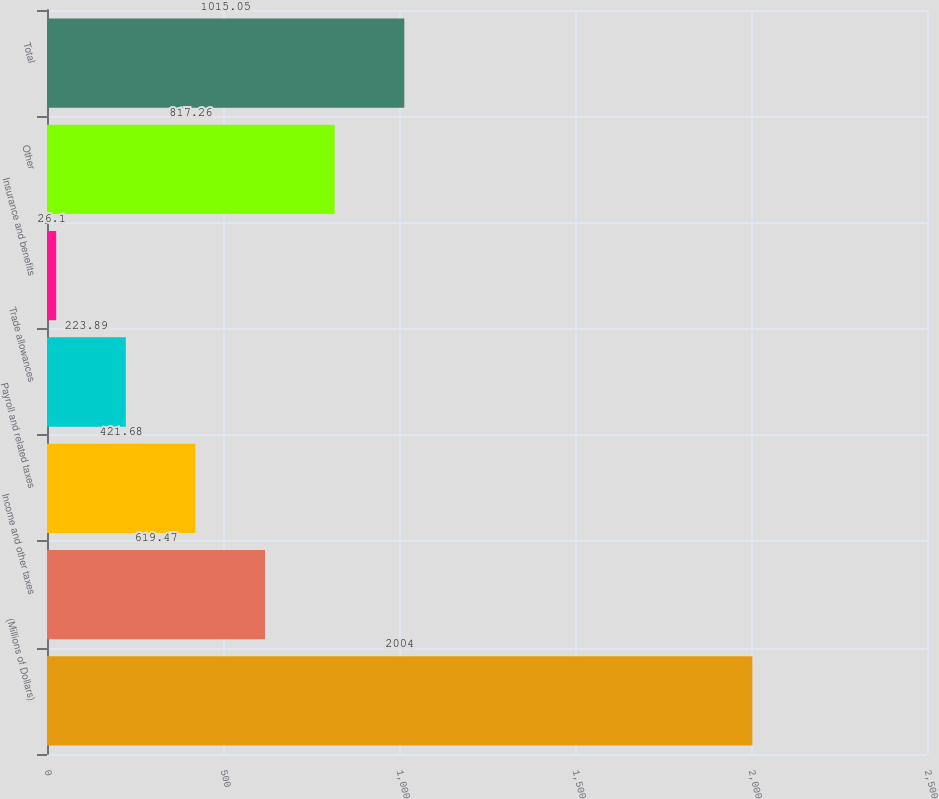<chart> <loc_0><loc_0><loc_500><loc_500><bar_chart><fcel>(Millions of Dollars)<fcel>Income and other taxes<fcel>Payroll and related taxes<fcel>Trade allowances<fcel>Insurance and benefits<fcel>Other<fcel>Total<nl><fcel>2004<fcel>619.47<fcel>421.68<fcel>223.89<fcel>26.1<fcel>817.26<fcel>1015.05<nl></chart> 